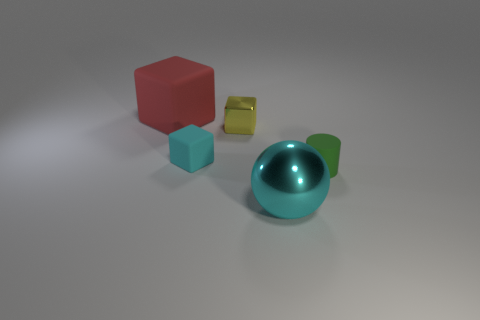Are there an equal number of big red objects that are in front of the small cyan matte object and cylinders?
Your answer should be compact. No. Do the red rubber cube and the ball have the same size?
Your answer should be compact. Yes. What material is the object that is on the left side of the small green thing and in front of the cyan matte cube?
Offer a terse response. Metal. What number of other matte objects have the same shape as the green matte object?
Make the answer very short. 0. There is a large thing that is behind the shiny cube; what is its material?
Give a very brief answer. Rubber. Is the number of cyan spheres behind the large cyan shiny sphere less than the number of small green matte things?
Your answer should be compact. Yes. Is the shape of the red object the same as the green object?
Make the answer very short. No. Are there any other things that have the same shape as the cyan metallic thing?
Give a very brief answer. No. Is there a green thing?
Your answer should be very brief. Yes. Is the shape of the red matte object the same as the big thing that is on the right side of the red matte object?
Ensure brevity in your answer.  No. 